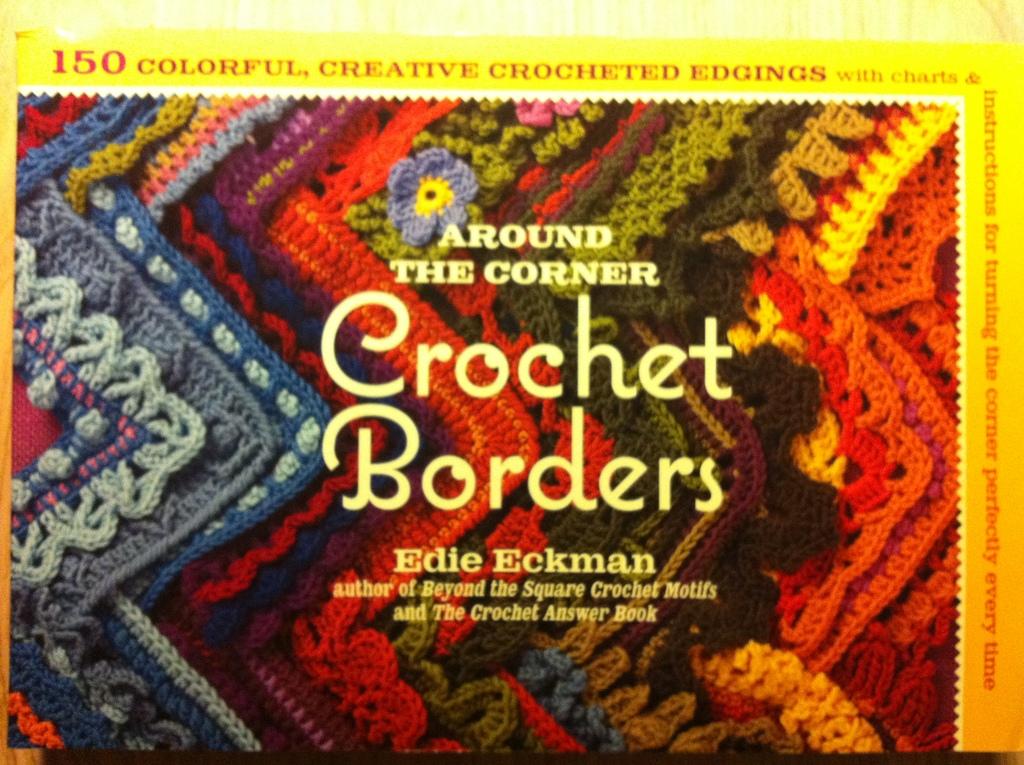What is the title of this?
Give a very brief answer. Crochet borders. Who wrote this book?
Your response must be concise. Edie eckman. 